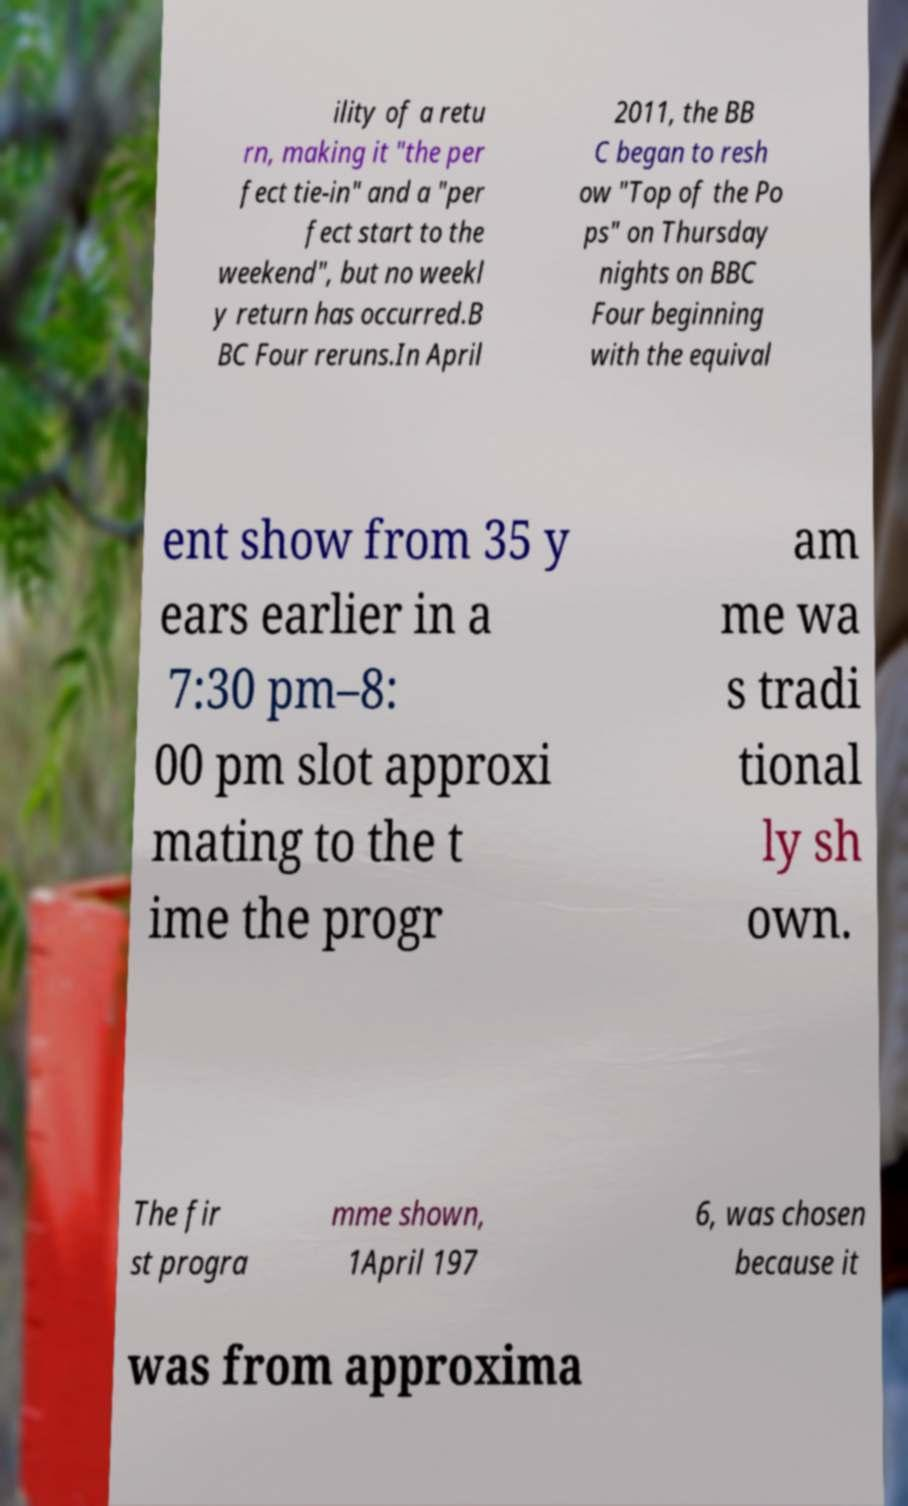Could you assist in decoding the text presented in this image and type it out clearly? ility of a retu rn, making it "the per fect tie-in" and a "per fect start to the weekend", but no weekl y return has occurred.B BC Four reruns.In April 2011, the BB C began to resh ow "Top of the Po ps" on Thursday nights on BBC Four beginning with the equival ent show from 35 y ears earlier in a 7:30 pm–8: 00 pm slot approxi mating to the t ime the progr am me wa s tradi tional ly sh own. The fir st progra mme shown, 1April 197 6, was chosen because it was from approxima 